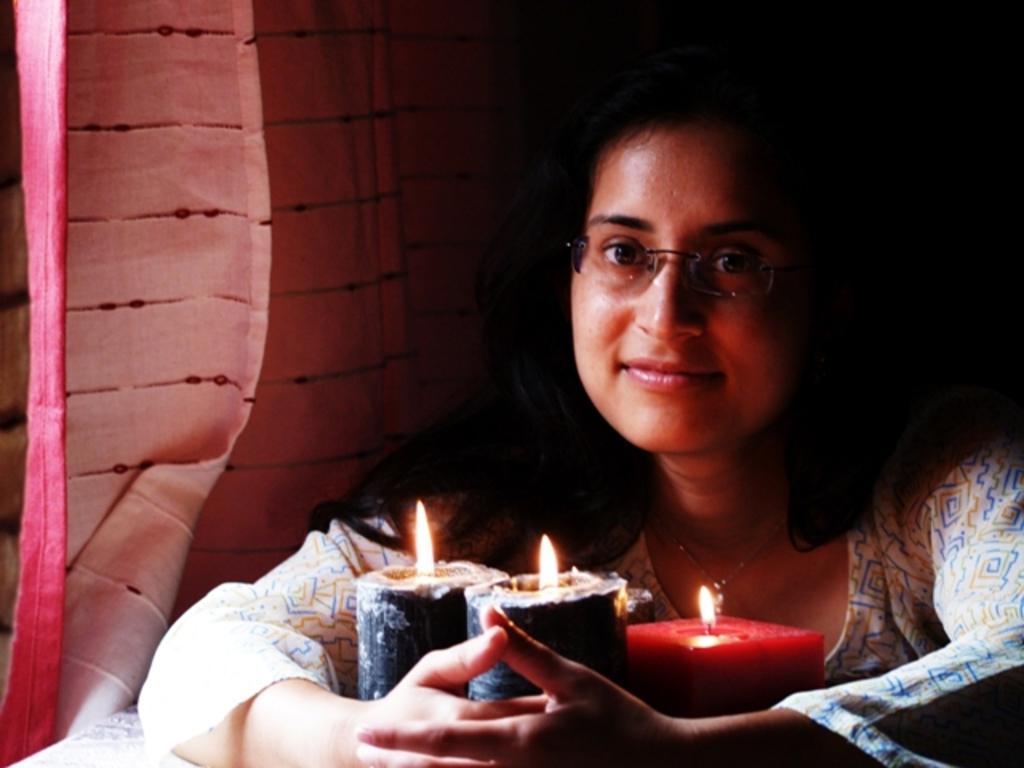Please provide a concise description of this image. In this image we can see a lady wearing glasses. At the bottom there are candles. In the background there is a curtain. 